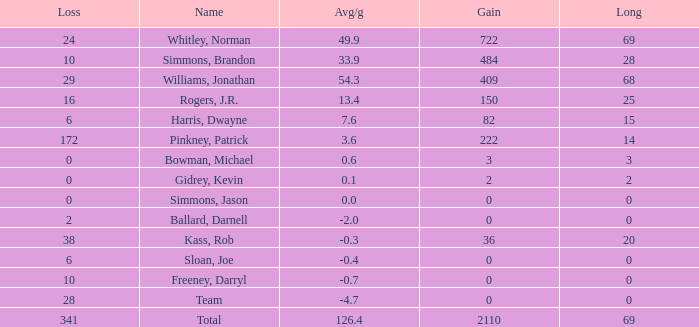What is the highest Loss, when Long is greater than 0, when Gain is greater than 484, and when Avg/g is greater than 126.4? None. 